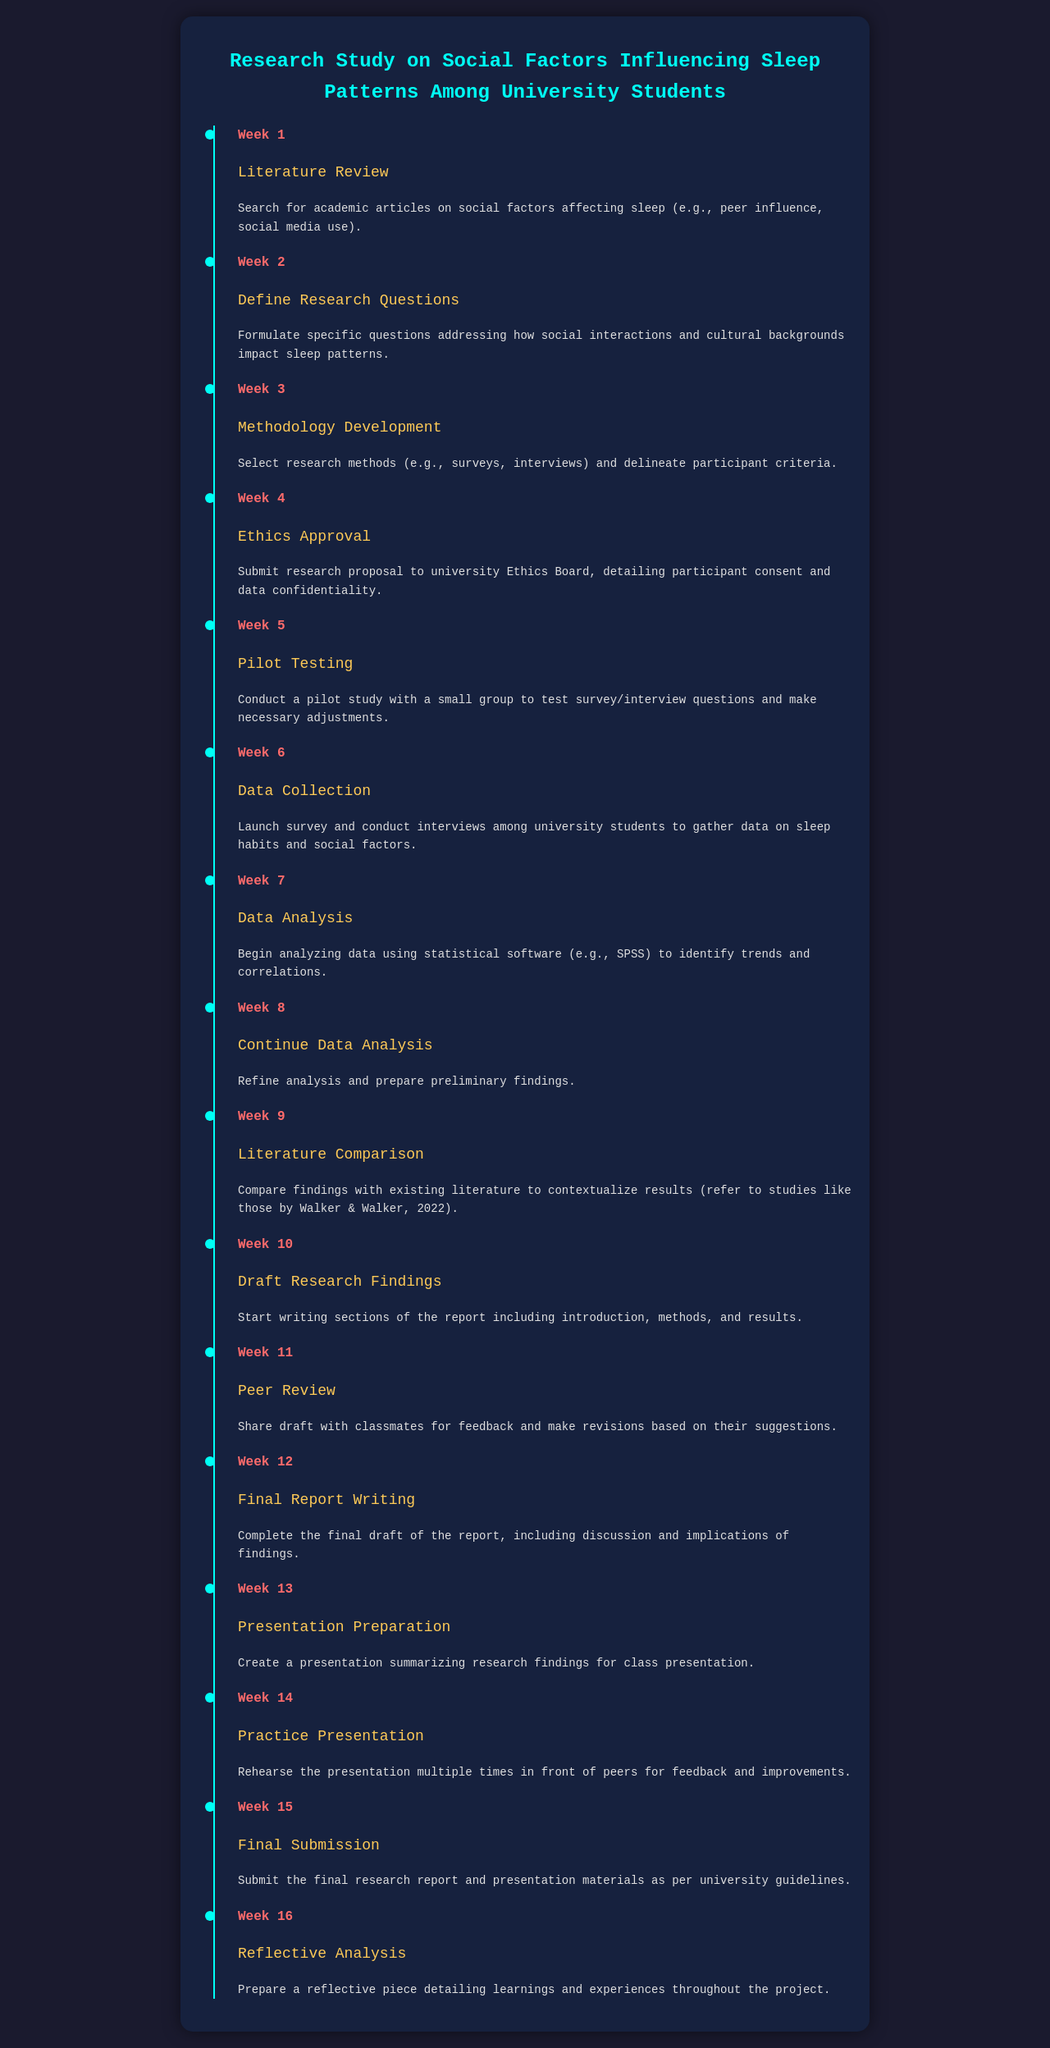What task is scheduled for Week 1? The document specifies that Week 1 involves conducting a Literature Review to search for academic articles on social factors affecting sleep.
Answer: Literature Review What is the focus of the research questions defined in Week 2? In Week 2, the focus is on formulating questions addressing how social interactions and cultural backgrounds impact sleep patterns.
Answer: Social interactions and cultural backgrounds How many weeks are allocated for data collection? The timeline indicates that data collection takes place in Week 6, which is one week.
Answer: 1 week What is the main method of data analysis mentioned for Week 7? The main method for data analysis as mentioned in Week 7 is using statistical software, specifically SPSS.
Answer: SPSS What task is scheduled in Week 10? The task scheduled for Week 10 includes drafting research findings and starting to write sections of the report such as introduction, methods, and results.
Answer: Draft Research Findings What specific activity occurs in Week 13? The specific activity that occurs in Week 13 is preparing a presentation summarizing the research findings for class presentation.
Answer: Presentation Preparation Which week is designated for Ethics Approval? The document specifies that Ethics Approval is to be submitted in Week 4.
Answer: Week 4 How is student feedback incorporated into the project? Feedback from classmates is incorporated during the peer review phase scheduled in Week 11 to revise the draft based on their suggestions.
Answer: Peer Review What is the final task listed in the schedule? The final task as per the timeline is the Reflective Analysis in Week 16, detailing learnings and experiences throughout the project.
Answer: Reflective Analysis 